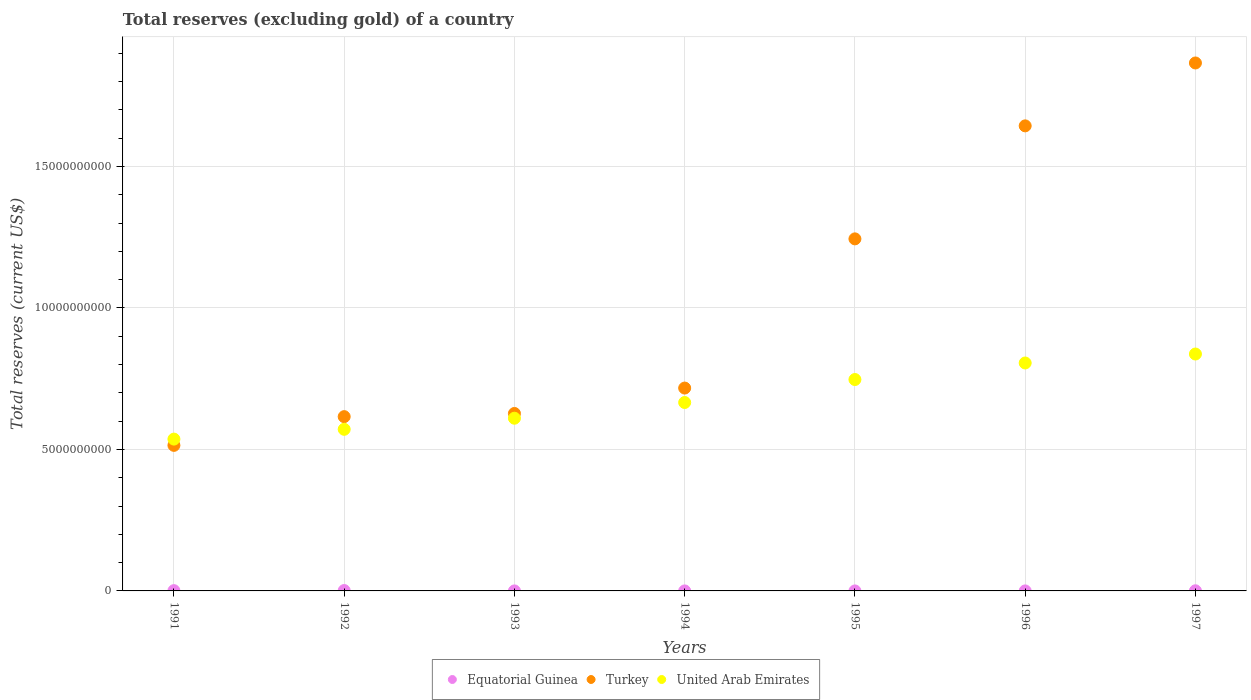What is the total reserves (excluding gold) in United Arab Emirates in 1991?
Your answer should be compact. 5.37e+09. Across all years, what is the maximum total reserves (excluding gold) in United Arab Emirates?
Your answer should be very brief. 8.37e+09. Across all years, what is the minimum total reserves (excluding gold) in Equatorial Guinea?
Your response must be concise. 4.08e+04. In which year was the total reserves (excluding gold) in United Arab Emirates minimum?
Your response must be concise. 1991. What is the total total reserves (excluding gold) in Turkey in the graph?
Ensure brevity in your answer.  7.23e+1. What is the difference between the total reserves (excluding gold) in United Arab Emirates in 1994 and that in 1997?
Offer a very short reply. -1.71e+09. What is the difference between the total reserves (excluding gold) in Equatorial Guinea in 1991 and the total reserves (excluding gold) in United Arab Emirates in 1994?
Your response must be concise. -6.65e+09. What is the average total reserves (excluding gold) in United Arab Emirates per year?
Offer a very short reply. 6.82e+09. In the year 1997, what is the difference between the total reserves (excluding gold) in Equatorial Guinea and total reserves (excluding gold) in Turkey?
Ensure brevity in your answer.  -1.87e+1. What is the ratio of the total reserves (excluding gold) in Equatorial Guinea in 1991 to that in 1997?
Ensure brevity in your answer.  1.92. What is the difference between the highest and the second highest total reserves (excluding gold) in Equatorial Guinea?
Provide a succinct answer. 3.93e+06. What is the difference between the highest and the lowest total reserves (excluding gold) in Turkey?
Give a very brief answer. 1.35e+1. Is the sum of the total reserves (excluding gold) in Equatorial Guinea in 1992 and 1996 greater than the maximum total reserves (excluding gold) in Turkey across all years?
Give a very brief answer. No. Is the total reserves (excluding gold) in Turkey strictly greater than the total reserves (excluding gold) in Equatorial Guinea over the years?
Provide a short and direct response. Yes. What is the difference between two consecutive major ticks on the Y-axis?
Ensure brevity in your answer.  5.00e+09. Does the graph contain any zero values?
Provide a short and direct response. No. How many legend labels are there?
Offer a very short reply. 3. How are the legend labels stacked?
Keep it short and to the point. Horizontal. What is the title of the graph?
Offer a very short reply. Total reserves (excluding gold) of a country. Does "Barbados" appear as one of the legend labels in the graph?
Make the answer very short. No. What is the label or title of the Y-axis?
Your response must be concise. Total reserves (current US$). What is the Total reserves (current US$) of Equatorial Guinea in 1991?
Your response must be concise. 9.47e+06. What is the Total reserves (current US$) in Turkey in 1991?
Provide a short and direct response. 5.14e+09. What is the Total reserves (current US$) of United Arab Emirates in 1991?
Offer a very short reply. 5.37e+09. What is the Total reserves (current US$) of Equatorial Guinea in 1992?
Your response must be concise. 1.34e+07. What is the Total reserves (current US$) of Turkey in 1992?
Provide a succinct answer. 6.16e+09. What is the Total reserves (current US$) in United Arab Emirates in 1992?
Give a very brief answer. 5.71e+09. What is the Total reserves (current US$) of Equatorial Guinea in 1993?
Give a very brief answer. 4.81e+05. What is the Total reserves (current US$) of Turkey in 1993?
Provide a short and direct response. 6.27e+09. What is the Total reserves (current US$) of United Arab Emirates in 1993?
Give a very brief answer. 6.10e+09. What is the Total reserves (current US$) in Equatorial Guinea in 1994?
Your answer should be very brief. 3.90e+05. What is the Total reserves (current US$) in Turkey in 1994?
Your answer should be very brief. 7.17e+09. What is the Total reserves (current US$) in United Arab Emirates in 1994?
Ensure brevity in your answer.  6.66e+09. What is the Total reserves (current US$) of Equatorial Guinea in 1995?
Offer a very short reply. 4.08e+04. What is the Total reserves (current US$) in Turkey in 1995?
Your answer should be very brief. 1.24e+1. What is the Total reserves (current US$) in United Arab Emirates in 1995?
Provide a short and direct response. 7.47e+09. What is the Total reserves (current US$) of Equatorial Guinea in 1996?
Make the answer very short. 5.16e+05. What is the Total reserves (current US$) in Turkey in 1996?
Your answer should be very brief. 1.64e+1. What is the Total reserves (current US$) in United Arab Emirates in 1996?
Your answer should be very brief. 8.06e+09. What is the Total reserves (current US$) of Equatorial Guinea in 1997?
Make the answer very short. 4.93e+06. What is the Total reserves (current US$) in Turkey in 1997?
Give a very brief answer. 1.87e+1. What is the Total reserves (current US$) of United Arab Emirates in 1997?
Ensure brevity in your answer.  8.37e+09. Across all years, what is the maximum Total reserves (current US$) of Equatorial Guinea?
Your answer should be very brief. 1.34e+07. Across all years, what is the maximum Total reserves (current US$) in Turkey?
Offer a very short reply. 1.87e+1. Across all years, what is the maximum Total reserves (current US$) of United Arab Emirates?
Your answer should be very brief. 8.37e+09. Across all years, what is the minimum Total reserves (current US$) of Equatorial Guinea?
Give a very brief answer. 4.08e+04. Across all years, what is the minimum Total reserves (current US$) in Turkey?
Your answer should be very brief. 5.14e+09. Across all years, what is the minimum Total reserves (current US$) in United Arab Emirates?
Your response must be concise. 5.37e+09. What is the total Total reserves (current US$) of Equatorial Guinea in the graph?
Make the answer very short. 2.92e+07. What is the total Total reserves (current US$) of Turkey in the graph?
Make the answer very short. 7.23e+1. What is the total Total reserves (current US$) in United Arab Emirates in the graph?
Your answer should be very brief. 4.77e+1. What is the difference between the Total reserves (current US$) of Equatorial Guinea in 1991 and that in 1992?
Make the answer very short. -3.93e+06. What is the difference between the Total reserves (current US$) of Turkey in 1991 and that in 1992?
Ensure brevity in your answer.  -1.02e+09. What is the difference between the Total reserves (current US$) of United Arab Emirates in 1991 and that in 1992?
Your answer should be very brief. -3.46e+08. What is the difference between the Total reserves (current US$) in Equatorial Guinea in 1991 and that in 1993?
Make the answer very short. 8.99e+06. What is the difference between the Total reserves (current US$) in Turkey in 1991 and that in 1993?
Provide a succinct answer. -1.13e+09. What is the difference between the Total reserves (current US$) of United Arab Emirates in 1991 and that in 1993?
Your answer should be very brief. -7.38e+08. What is the difference between the Total reserves (current US$) in Equatorial Guinea in 1991 and that in 1994?
Provide a short and direct response. 9.08e+06. What is the difference between the Total reserves (current US$) of Turkey in 1991 and that in 1994?
Offer a very short reply. -2.03e+09. What is the difference between the Total reserves (current US$) in United Arab Emirates in 1991 and that in 1994?
Provide a short and direct response. -1.29e+09. What is the difference between the Total reserves (current US$) of Equatorial Guinea in 1991 and that in 1995?
Ensure brevity in your answer.  9.43e+06. What is the difference between the Total reserves (current US$) of Turkey in 1991 and that in 1995?
Provide a short and direct response. -7.30e+09. What is the difference between the Total reserves (current US$) of United Arab Emirates in 1991 and that in 1995?
Your response must be concise. -2.11e+09. What is the difference between the Total reserves (current US$) of Equatorial Guinea in 1991 and that in 1996?
Give a very brief answer. 8.96e+06. What is the difference between the Total reserves (current US$) of Turkey in 1991 and that in 1996?
Your answer should be compact. -1.13e+1. What is the difference between the Total reserves (current US$) in United Arab Emirates in 1991 and that in 1996?
Provide a short and direct response. -2.69e+09. What is the difference between the Total reserves (current US$) of Equatorial Guinea in 1991 and that in 1997?
Make the answer very short. 4.54e+06. What is the difference between the Total reserves (current US$) in Turkey in 1991 and that in 1997?
Your response must be concise. -1.35e+1. What is the difference between the Total reserves (current US$) of United Arab Emirates in 1991 and that in 1997?
Offer a very short reply. -3.01e+09. What is the difference between the Total reserves (current US$) in Equatorial Guinea in 1992 and that in 1993?
Ensure brevity in your answer.  1.29e+07. What is the difference between the Total reserves (current US$) in Turkey in 1992 and that in 1993?
Your answer should be compact. -1.12e+08. What is the difference between the Total reserves (current US$) in United Arab Emirates in 1992 and that in 1993?
Ensure brevity in your answer.  -3.92e+08. What is the difference between the Total reserves (current US$) of Equatorial Guinea in 1992 and that in 1994?
Offer a very short reply. 1.30e+07. What is the difference between the Total reserves (current US$) in Turkey in 1992 and that in 1994?
Your response must be concise. -1.01e+09. What is the difference between the Total reserves (current US$) of United Arab Emirates in 1992 and that in 1994?
Offer a very short reply. -9.47e+08. What is the difference between the Total reserves (current US$) of Equatorial Guinea in 1992 and that in 1995?
Keep it short and to the point. 1.34e+07. What is the difference between the Total reserves (current US$) of Turkey in 1992 and that in 1995?
Your answer should be very brief. -6.28e+09. What is the difference between the Total reserves (current US$) of United Arab Emirates in 1992 and that in 1995?
Provide a short and direct response. -1.76e+09. What is the difference between the Total reserves (current US$) of Equatorial Guinea in 1992 and that in 1996?
Provide a short and direct response. 1.29e+07. What is the difference between the Total reserves (current US$) in Turkey in 1992 and that in 1996?
Your answer should be compact. -1.03e+1. What is the difference between the Total reserves (current US$) of United Arab Emirates in 1992 and that in 1996?
Your answer should be very brief. -2.34e+09. What is the difference between the Total reserves (current US$) of Equatorial Guinea in 1992 and that in 1997?
Provide a short and direct response. 8.48e+06. What is the difference between the Total reserves (current US$) in Turkey in 1992 and that in 1997?
Your answer should be compact. -1.25e+1. What is the difference between the Total reserves (current US$) in United Arab Emirates in 1992 and that in 1997?
Provide a short and direct response. -2.66e+09. What is the difference between the Total reserves (current US$) of Equatorial Guinea in 1993 and that in 1994?
Offer a very short reply. 9.05e+04. What is the difference between the Total reserves (current US$) of Turkey in 1993 and that in 1994?
Make the answer very short. -8.98e+08. What is the difference between the Total reserves (current US$) of United Arab Emirates in 1993 and that in 1994?
Your answer should be compact. -5.55e+08. What is the difference between the Total reserves (current US$) in Equatorial Guinea in 1993 and that in 1995?
Your answer should be very brief. 4.40e+05. What is the difference between the Total reserves (current US$) of Turkey in 1993 and that in 1995?
Offer a very short reply. -6.17e+09. What is the difference between the Total reserves (current US$) of United Arab Emirates in 1993 and that in 1995?
Provide a short and direct response. -1.37e+09. What is the difference between the Total reserves (current US$) of Equatorial Guinea in 1993 and that in 1996?
Provide a succinct answer. -3.57e+04. What is the difference between the Total reserves (current US$) in Turkey in 1993 and that in 1996?
Give a very brief answer. -1.02e+1. What is the difference between the Total reserves (current US$) of United Arab Emirates in 1993 and that in 1996?
Keep it short and to the point. -1.95e+09. What is the difference between the Total reserves (current US$) of Equatorial Guinea in 1993 and that in 1997?
Provide a succinct answer. -4.45e+06. What is the difference between the Total reserves (current US$) in Turkey in 1993 and that in 1997?
Make the answer very short. -1.24e+1. What is the difference between the Total reserves (current US$) in United Arab Emirates in 1993 and that in 1997?
Offer a terse response. -2.27e+09. What is the difference between the Total reserves (current US$) in Equatorial Guinea in 1994 and that in 1995?
Your answer should be compact. 3.50e+05. What is the difference between the Total reserves (current US$) of Turkey in 1994 and that in 1995?
Provide a short and direct response. -5.27e+09. What is the difference between the Total reserves (current US$) of United Arab Emirates in 1994 and that in 1995?
Keep it short and to the point. -8.12e+08. What is the difference between the Total reserves (current US$) in Equatorial Guinea in 1994 and that in 1996?
Make the answer very short. -1.26e+05. What is the difference between the Total reserves (current US$) in Turkey in 1994 and that in 1996?
Provide a short and direct response. -9.27e+09. What is the difference between the Total reserves (current US$) in United Arab Emirates in 1994 and that in 1996?
Make the answer very short. -1.40e+09. What is the difference between the Total reserves (current US$) in Equatorial Guinea in 1994 and that in 1997?
Provide a short and direct response. -4.54e+06. What is the difference between the Total reserves (current US$) in Turkey in 1994 and that in 1997?
Offer a terse response. -1.15e+1. What is the difference between the Total reserves (current US$) of United Arab Emirates in 1994 and that in 1997?
Offer a very short reply. -1.71e+09. What is the difference between the Total reserves (current US$) in Equatorial Guinea in 1995 and that in 1996?
Offer a very short reply. -4.76e+05. What is the difference between the Total reserves (current US$) of Turkey in 1995 and that in 1996?
Provide a short and direct response. -3.99e+09. What is the difference between the Total reserves (current US$) of United Arab Emirates in 1995 and that in 1996?
Your answer should be compact. -5.85e+08. What is the difference between the Total reserves (current US$) in Equatorial Guinea in 1995 and that in 1997?
Offer a terse response. -4.89e+06. What is the difference between the Total reserves (current US$) in Turkey in 1995 and that in 1997?
Offer a very short reply. -6.22e+09. What is the difference between the Total reserves (current US$) in United Arab Emirates in 1995 and that in 1997?
Provide a short and direct response. -9.01e+08. What is the difference between the Total reserves (current US$) of Equatorial Guinea in 1996 and that in 1997?
Give a very brief answer. -4.42e+06. What is the difference between the Total reserves (current US$) in Turkey in 1996 and that in 1997?
Offer a terse response. -2.22e+09. What is the difference between the Total reserves (current US$) in United Arab Emirates in 1996 and that in 1997?
Your answer should be compact. -3.17e+08. What is the difference between the Total reserves (current US$) in Equatorial Guinea in 1991 and the Total reserves (current US$) in Turkey in 1992?
Your response must be concise. -6.15e+09. What is the difference between the Total reserves (current US$) in Equatorial Guinea in 1991 and the Total reserves (current US$) in United Arab Emirates in 1992?
Ensure brevity in your answer.  -5.70e+09. What is the difference between the Total reserves (current US$) of Turkey in 1991 and the Total reserves (current US$) of United Arab Emirates in 1992?
Ensure brevity in your answer.  -5.68e+08. What is the difference between the Total reserves (current US$) of Equatorial Guinea in 1991 and the Total reserves (current US$) of Turkey in 1993?
Offer a terse response. -6.26e+09. What is the difference between the Total reserves (current US$) in Equatorial Guinea in 1991 and the Total reserves (current US$) in United Arab Emirates in 1993?
Your response must be concise. -6.09e+09. What is the difference between the Total reserves (current US$) of Turkey in 1991 and the Total reserves (current US$) of United Arab Emirates in 1993?
Your response must be concise. -9.60e+08. What is the difference between the Total reserves (current US$) in Equatorial Guinea in 1991 and the Total reserves (current US$) in Turkey in 1994?
Offer a terse response. -7.16e+09. What is the difference between the Total reserves (current US$) of Equatorial Guinea in 1991 and the Total reserves (current US$) of United Arab Emirates in 1994?
Ensure brevity in your answer.  -6.65e+09. What is the difference between the Total reserves (current US$) of Turkey in 1991 and the Total reserves (current US$) of United Arab Emirates in 1994?
Your response must be concise. -1.51e+09. What is the difference between the Total reserves (current US$) of Equatorial Guinea in 1991 and the Total reserves (current US$) of Turkey in 1995?
Provide a succinct answer. -1.24e+1. What is the difference between the Total reserves (current US$) of Equatorial Guinea in 1991 and the Total reserves (current US$) of United Arab Emirates in 1995?
Your answer should be compact. -7.46e+09. What is the difference between the Total reserves (current US$) of Turkey in 1991 and the Total reserves (current US$) of United Arab Emirates in 1995?
Offer a terse response. -2.33e+09. What is the difference between the Total reserves (current US$) of Equatorial Guinea in 1991 and the Total reserves (current US$) of Turkey in 1996?
Ensure brevity in your answer.  -1.64e+1. What is the difference between the Total reserves (current US$) of Equatorial Guinea in 1991 and the Total reserves (current US$) of United Arab Emirates in 1996?
Provide a short and direct response. -8.05e+09. What is the difference between the Total reserves (current US$) of Turkey in 1991 and the Total reserves (current US$) of United Arab Emirates in 1996?
Offer a terse response. -2.91e+09. What is the difference between the Total reserves (current US$) in Equatorial Guinea in 1991 and the Total reserves (current US$) in Turkey in 1997?
Ensure brevity in your answer.  -1.86e+1. What is the difference between the Total reserves (current US$) of Equatorial Guinea in 1991 and the Total reserves (current US$) of United Arab Emirates in 1997?
Make the answer very short. -8.36e+09. What is the difference between the Total reserves (current US$) of Turkey in 1991 and the Total reserves (current US$) of United Arab Emirates in 1997?
Provide a succinct answer. -3.23e+09. What is the difference between the Total reserves (current US$) of Equatorial Guinea in 1992 and the Total reserves (current US$) of Turkey in 1993?
Give a very brief answer. -6.26e+09. What is the difference between the Total reserves (current US$) in Equatorial Guinea in 1992 and the Total reserves (current US$) in United Arab Emirates in 1993?
Give a very brief answer. -6.09e+09. What is the difference between the Total reserves (current US$) of Turkey in 1992 and the Total reserves (current US$) of United Arab Emirates in 1993?
Provide a short and direct response. 5.57e+07. What is the difference between the Total reserves (current US$) of Equatorial Guinea in 1992 and the Total reserves (current US$) of Turkey in 1994?
Ensure brevity in your answer.  -7.16e+09. What is the difference between the Total reserves (current US$) of Equatorial Guinea in 1992 and the Total reserves (current US$) of United Arab Emirates in 1994?
Keep it short and to the point. -6.65e+09. What is the difference between the Total reserves (current US$) of Turkey in 1992 and the Total reserves (current US$) of United Arab Emirates in 1994?
Offer a terse response. -4.99e+08. What is the difference between the Total reserves (current US$) in Equatorial Guinea in 1992 and the Total reserves (current US$) in Turkey in 1995?
Provide a succinct answer. -1.24e+1. What is the difference between the Total reserves (current US$) in Equatorial Guinea in 1992 and the Total reserves (current US$) in United Arab Emirates in 1995?
Provide a short and direct response. -7.46e+09. What is the difference between the Total reserves (current US$) in Turkey in 1992 and the Total reserves (current US$) in United Arab Emirates in 1995?
Provide a short and direct response. -1.31e+09. What is the difference between the Total reserves (current US$) in Equatorial Guinea in 1992 and the Total reserves (current US$) in Turkey in 1996?
Ensure brevity in your answer.  -1.64e+1. What is the difference between the Total reserves (current US$) of Equatorial Guinea in 1992 and the Total reserves (current US$) of United Arab Emirates in 1996?
Your answer should be very brief. -8.04e+09. What is the difference between the Total reserves (current US$) in Turkey in 1992 and the Total reserves (current US$) in United Arab Emirates in 1996?
Offer a very short reply. -1.90e+09. What is the difference between the Total reserves (current US$) of Equatorial Guinea in 1992 and the Total reserves (current US$) of Turkey in 1997?
Ensure brevity in your answer.  -1.86e+1. What is the difference between the Total reserves (current US$) of Equatorial Guinea in 1992 and the Total reserves (current US$) of United Arab Emirates in 1997?
Offer a very short reply. -8.36e+09. What is the difference between the Total reserves (current US$) in Turkey in 1992 and the Total reserves (current US$) in United Arab Emirates in 1997?
Provide a short and direct response. -2.21e+09. What is the difference between the Total reserves (current US$) of Equatorial Guinea in 1993 and the Total reserves (current US$) of Turkey in 1994?
Offer a very short reply. -7.17e+09. What is the difference between the Total reserves (current US$) of Equatorial Guinea in 1993 and the Total reserves (current US$) of United Arab Emirates in 1994?
Ensure brevity in your answer.  -6.66e+09. What is the difference between the Total reserves (current US$) of Turkey in 1993 and the Total reserves (current US$) of United Arab Emirates in 1994?
Your answer should be compact. -3.87e+08. What is the difference between the Total reserves (current US$) in Equatorial Guinea in 1993 and the Total reserves (current US$) in Turkey in 1995?
Offer a terse response. -1.24e+1. What is the difference between the Total reserves (current US$) in Equatorial Guinea in 1993 and the Total reserves (current US$) in United Arab Emirates in 1995?
Make the answer very short. -7.47e+09. What is the difference between the Total reserves (current US$) of Turkey in 1993 and the Total reserves (current US$) of United Arab Emirates in 1995?
Your answer should be compact. -1.20e+09. What is the difference between the Total reserves (current US$) of Equatorial Guinea in 1993 and the Total reserves (current US$) of Turkey in 1996?
Make the answer very short. -1.64e+1. What is the difference between the Total reserves (current US$) of Equatorial Guinea in 1993 and the Total reserves (current US$) of United Arab Emirates in 1996?
Offer a very short reply. -8.06e+09. What is the difference between the Total reserves (current US$) of Turkey in 1993 and the Total reserves (current US$) of United Arab Emirates in 1996?
Offer a terse response. -1.78e+09. What is the difference between the Total reserves (current US$) of Equatorial Guinea in 1993 and the Total reserves (current US$) of Turkey in 1997?
Provide a succinct answer. -1.87e+1. What is the difference between the Total reserves (current US$) in Equatorial Guinea in 1993 and the Total reserves (current US$) in United Arab Emirates in 1997?
Ensure brevity in your answer.  -8.37e+09. What is the difference between the Total reserves (current US$) of Turkey in 1993 and the Total reserves (current US$) of United Arab Emirates in 1997?
Your answer should be compact. -2.10e+09. What is the difference between the Total reserves (current US$) in Equatorial Guinea in 1994 and the Total reserves (current US$) in Turkey in 1995?
Provide a succinct answer. -1.24e+1. What is the difference between the Total reserves (current US$) of Equatorial Guinea in 1994 and the Total reserves (current US$) of United Arab Emirates in 1995?
Make the answer very short. -7.47e+09. What is the difference between the Total reserves (current US$) in Turkey in 1994 and the Total reserves (current US$) in United Arab Emirates in 1995?
Your answer should be compact. -3.02e+08. What is the difference between the Total reserves (current US$) in Equatorial Guinea in 1994 and the Total reserves (current US$) in Turkey in 1996?
Offer a terse response. -1.64e+1. What is the difference between the Total reserves (current US$) in Equatorial Guinea in 1994 and the Total reserves (current US$) in United Arab Emirates in 1996?
Provide a succinct answer. -8.06e+09. What is the difference between the Total reserves (current US$) in Turkey in 1994 and the Total reserves (current US$) in United Arab Emirates in 1996?
Keep it short and to the point. -8.86e+08. What is the difference between the Total reserves (current US$) in Equatorial Guinea in 1994 and the Total reserves (current US$) in Turkey in 1997?
Ensure brevity in your answer.  -1.87e+1. What is the difference between the Total reserves (current US$) in Equatorial Guinea in 1994 and the Total reserves (current US$) in United Arab Emirates in 1997?
Make the answer very short. -8.37e+09. What is the difference between the Total reserves (current US$) of Turkey in 1994 and the Total reserves (current US$) of United Arab Emirates in 1997?
Keep it short and to the point. -1.20e+09. What is the difference between the Total reserves (current US$) of Equatorial Guinea in 1995 and the Total reserves (current US$) of Turkey in 1996?
Provide a short and direct response. -1.64e+1. What is the difference between the Total reserves (current US$) in Equatorial Guinea in 1995 and the Total reserves (current US$) in United Arab Emirates in 1996?
Offer a terse response. -8.06e+09. What is the difference between the Total reserves (current US$) of Turkey in 1995 and the Total reserves (current US$) of United Arab Emirates in 1996?
Your answer should be very brief. 4.39e+09. What is the difference between the Total reserves (current US$) of Equatorial Guinea in 1995 and the Total reserves (current US$) of Turkey in 1997?
Make the answer very short. -1.87e+1. What is the difference between the Total reserves (current US$) in Equatorial Guinea in 1995 and the Total reserves (current US$) in United Arab Emirates in 1997?
Keep it short and to the point. -8.37e+09. What is the difference between the Total reserves (current US$) of Turkey in 1995 and the Total reserves (current US$) of United Arab Emirates in 1997?
Make the answer very short. 4.07e+09. What is the difference between the Total reserves (current US$) of Equatorial Guinea in 1996 and the Total reserves (current US$) of Turkey in 1997?
Keep it short and to the point. -1.87e+1. What is the difference between the Total reserves (current US$) of Equatorial Guinea in 1996 and the Total reserves (current US$) of United Arab Emirates in 1997?
Give a very brief answer. -8.37e+09. What is the difference between the Total reserves (current US$) of Turkey in 1996 and the Total reserves (current US$) of United Arab Emirates in 1997?
Offer a terse response. 8.06e+09. What is the average Total reserves (current US$) in Equatorial Guinea per year?
Offer a terse response. 4.18e+06. What is the average Total reserves (current US$) in Turkey per year?
Offer a terse response. 1.03e+1. What is the average Total reserves (current US$) of United Arab Emirates per year?
Keep it short and to the point. 6.82e+09. In the year 1991, what is the difference between the Total reserves (current US$) of Equatorial Guinea and Total reserves (current US$) of Turkey?
Keep it short and to the point. -5.13e+09. In the year 1991, what is the difference between the Total reserves (current US$) in Equatorial Guinea and Total reserves (current US$) in United Arab Emirates?
Offer a very short reply. -5.36e+09. In the year 1991, what is the difference between the Total reserves (current US$) in Turkey and Total reserves (current US$) in United Arab Emirates?
Your answer should be very brief. -2.21e+08. In the year 1992, what is the difference between the Total reserves (current US$) of Equatorial Guinea and Total reserves (current US$) of Turkey?
Your answer should be compact. -6.15e+09. In the year 1992, what is the difference between the Total reserves (current US$) in Equatorial Guinea and Total reserves (current US$) in United Arab Emirates?
Your response must be concise. -5.70e+09. In the year 1992, what is the difference between the Total reserves (current US$) in Turkey and Total reserves (current US$) in United Arab Emirates?
Your answer should be compact. 4.48e+08. In the year 1993, what is the difference between the Total reserves (current US$) of Equatorial Guinea and Total reserves (current US$) of Turkey?
Offer a terse response. -6.27e+09. In the year 1993, what is the difference between the Total reserves (current US$) in Equatorial Guinea and Total reserves (current US$) in United Arab Emirates?
Ensure brevity in your answer.  -6.10e+09. In the year 1993, what is the difference between the Total reserves (current US$) in Turkey and Total reserves (current US$) in United Arab Emirates?
Provide a succinct answer. 1.68e+08. In the year 1994, what is the difference between the Total reserves (current US$) of Equatorial Guinea and Total reserves (current US$) of Turkey?
Offer a terse response. -7.17e+09. In the year 1994, what is the difference between the Total reserves (current US$) of Equatorial Guinea and Total reserves (current US$) of United Arab Emirates?
Make the answer very short. -6.66e+09. In the year 1994, what is the difference between the Total reserves (current US$) in Turkey and Total reserves (current US$) in United Arab Emirates?
Ensure brevity in your answer.  5.11e+08. In the year 1995, what is the difference between the Total reserves (current US$) in Equatorial Guinea and Total reserves (current US$) in Turkey?
Make the answer very short. -1.24e+1. In the year 1995, what is the difference between the Total reserves (current US$) in Equatorial Guinea and Total reserves (current US$) in United Arab Emirates?
Ensure brevity in your answer.  -7.47e+09. In the year 1995, what is the difference between the Total reserves (current US$) in Turkey and Total reserves (current US$) in United Arab Emirates?
Your response must be concise. 4.97e+09. In the year 1996, what is the difference between the Total reserves (current US$) of Equatorial Guinea and Total reserves (current US$) of Turkey?
Your response must be concise. -1.64e+1. In the year 1996, what is the difference between the Total reserves (current US$) in Equatorial Guinea and Total reserves (current US$) in United Arab Emirates?
Your answer should be very brief. -8.05e+09. In the year 1996, what is the difference between the Total reserves (current US$) in Turkey and Total reserves (current US$) in United Arab Emirates?
Provide a succinct answer. 8.38e+09. In the year 1997, what is the difference between the Total reserves (current US$) in Equatorial Guinea and Total reserves (current US$) in Turkey?
Give a very brief answer. -1.87e+1. In the year 1997, what is the difference between the Total reserves (current US$) of Equatorial Guinea and Total reserves (current US$) of United Arab Emirates?
Offer a very short reply. -8.37e+09. In the year 1997, what is the difference between the Total reserves (current US$) in Turkey and Total reserves (current US$) in United Arab Emirates?
Keep it short and to the point. 1.03e+1. What is the ratio of the Total reserves (current US$) in Equatorial Guinea in 1991 to that in 1992?
Offer a terse response. 0.71. What is the ratio of the Total reserves (current US$) of Turkey in 1991 to that in 1992?
Ensure brevity in your answer.  0.84. What is the ratio of the Total reserves (current US$) in United Arab Emirates in 1991 to that in 1992?
Your answer should be compact. 0.94. What is the ratio of the Total reserves (current US$) of Equatorial Guinea in 1991 to that in 1993?
Offer a terse response. 19.7. What is the ratio of the Total reserves (current US$) in Turkey in 1991 to that in 1993?
Your answer should be very brief. 0.82. What is the ratio of the Total reserves (current US$) of United Arab Emirates in 1991 to that in 1993?
Provide a short and direct response. 0.88. What is the ratio of the Total reserves (current US$) in Equatorial Guinea in 1991 to that in 1994?
Your response must be concise. 24.27. What is the ratio of the Total reserves (current US$) in Turkey in 1991 to that in 1994?
Offer a terse response. 0.72. What is the ratio of the Total reserves (current US$) of United Arab Emirates in 1991 to that in 1994?
Your answer should be compact. 0.81. What is the ratio of the Total reserves (current US$) in Equatorial Guinea in 1991 to that in 1995?
Give a very brief answer. 232.13. What is the ratio of the Total reserves (current US$) of Turkey in 1991 to that in 1995?
Make the answer very short. 0.41. What is the ratio of the Total reserves (current US$) of United Arab Emirates in 1991 to that in 1995?
Provide a short and direct response. 0.72. What is the ratio of the Total reserves (current US$) in Equatorial Guinea in 1991 to that in 1996?
Provide a short and direct response. 18.34. What is the ratio of the Total reserves (current US$) of Turkey in 1991 to that in 1996?
Ensure brevity in your answer.  0.31. What is the ratio of the Total reserves (current US$) in United Arab Emirates in 1991 to that in 1996?
Your answer should be very brief. 0.67. What is the ratio of the Total reserves (current US$) of Equatorial Guinea in 1991 to that in 1997?
Offer a terse response. 1.92. What is the ratio of the Total reserves (current US$) of Turkey in 1991 to that in 1997?
Give a very brief answer. 0.28. What is the ratio of the Total reserves (current US$) of United Arab Emirates in 1991 to that in 1997?
Your answer should be compact. 0.64. What is the ratio of the Total reserves (current US$) of Equatorial Guinea in 1992 to that in 1993?
Offer a terse response. 27.89. What is the ratio of the Total reserves (current US$) in Turkey in 1992 to that in 1993?
Offer a terse response. 0.98. What is the ratio of the Total reserves (current US$) in United Arab Emirates in 1992 to that in 1993?
Your answer should be very brief. 0.94. What is the ratio of the Total reserves (current US$) in Equatorial Guinea in 1992 to that in 1994?
Offer a very short reply. 34.35. What is the ratio of the Total reserves (current US$) in Turkey in 1992 to that in 1994?
Your response must be concise. 0.86. What is the ratio of the Total reserves (current US$) of United Arab Emirates in 1992 to that in 1994?
Give a very brief answer. 0.86. What is the ratio of the Total reserves (current US$) in Equatorial Guinea in 1992 to that in 1995?
Ensure brevity in your answer.  328.54. What is the ratio of the Total reserves (current US$) in Turkey in 1992 to that in 1995?
Make the answer very short. 0.5. What is the ratio of the Total reserves (current US$) in United Arab Emirates in 1992 to that in 1995?
Provide a short and direct response. 0.76. What is the ratio of the Total reserves (current US$) in Equatorial Guinea in 1992 to that in 1996?
Give a very brief answer. 25.96. What is the ratio of the Total reserves (current US$) in Turkey in 1992 to that in 1996?
Offer a terse response. 0.37. What is the ratio of the Total reserves (current US$) in United Arab Emirates in 1992 to that in 1996?
Offer a very short reply. 0.71. What is the ratio of the Total reserves (current US$) of Equatorial Guinea in 1992 to that in 1997?
Make the answer very short. 2.72. What is the ratio of the Total reserves (current US$) of Turkey in 1992 to that in 1997?
Provide a short and direct response. 0.33. What is the ratio of the Total reserves (current US$) in United Arab Emirates in 1992 to that in 1997?
Ensure brevity in your answer.  0.68. What is the ratio of the Total reserves (current US$) of Equatorial Guinea in 1993 to that in 1994?
Your response must be concise. 1.23. What is the ratio of the Total reserves (current US$) in Turkey in 1993 to that in 1994?
Ensure brevity in your answer.  0.87. What is the ratio of the Total reserves (current US$) in United Arab Emirates in 1993 to that in 1994?
Keep it short and to the point. 0.92. What is the ratio of the Total reserves (current US$) of Equatorial Guinea in 1993 to that in 1995?
Provide a short and direct response. 11.78. What is the ratio of the Total reserves (current US$) of Turkey in 1993 to that in 1995?
Provide a succinct answer. 0.5. What is the ratio of the Total reserves (current US$) in United Arab Emirates in 1993 to that in 1995?
Your answer should be very brief. 0.82. What is the ratio of the Total reserves (current US$) in Equatorial Guinea in 1993 to that in 1996?
Your response must be concise. 0.93. What is the ratio of the Total reserves (current US$) in Turkey in 1993 to that in 1996?
Keep it short and to the point. 0.38. What is the ratio of the Total reserves (current US$) of United Arab Emirates in 1993 to that in 1996?
Ensure brevity in your answer.  0.76. What is the ratio of the Total reserves (current US$) in Equatorial Guinea in 1993 to that in 1997?
Keep it short and to the point. 0.1. What is the ratio of the Total reserves (current US$) of Turkey in 1993 to that in 1997?
Keep it short and to the point. 0.34. What is the ratio of the Total reserves (current US$) in United Arab Emirates in 1993 to that in 1997?
Provide a short and direct response. 0.73. What is the ratio of the Total reserves (current US$) in Equatorial Guinea in 1994 to that in 1995?
Your answer should be compact. 9.56. What is the ratio of the Total reserves (current US$) of Turkey in 1994 to that in 1995?
Offer a very short reply. 0.58. What is the ratio of the Total reserves (current US$) in United Arab Emirates in 1994 to that in 1995?
Your response must be concise. 0.89. What is the ratio of the Total reserves (current US$) of Equatorial Guinea in 1994 to that in 1996?
Your response must be concise. 0.76. What is the ratio of the Total reserves (current US$) of Turkey in 1994 to that in 1996?
Keep it short and to the point. 0.44. What is the ratio of the Total reserves (current US$) in United Arab Emirates in 1994 to that in 1996?
Keep it short and to the point. 0.83. What is the ratio of the Total reserves (current US$) in Equatorial Guinea in 1994 to that in 1997?
Offer a very short reply. 0.08. What is the ratio of the Total reserves (current US$) of Turkey in 1994 to that in 1997?
Offer a very short reply. 0.38. What is the ratio of the Total reserves (current US$) in United Arab Emirates in 1994 to that in 1997?
Ensure brevity in your answer.  0.8. What is the ratio of the Total reserves (current US$) of Equatorial Guinea in 1995 to that in 1996?
Your response must be concise. 0.08. What is the ratio of the Total reserves (current US$) in Turkey in 1995 to that in 1996?
Keep it short and to the point. 0.76. What is the ratio of the Total reserves (current US$) in United Arab Emirates in 1995 to that in 1996?
Make the answer very short. 0.93. What is the ratio of the Total reserves (current US$) of Equatorial Guinea in 1995 to that in 1997?
Keep it short and to the point. 0.01. What is the ratio of the Total reserves (current US$) in Turkey in 1995 to that in 1997?
Offer a terse response. 0.67. What is the ratio of the Total reserves (current US$) in United Arab Emirates in 1995 to that in 1997?
Make the answer very short. 0.89. What is the ratio of the Total reserves (current US$) of Equatorial Guinea in 1996 to that in 1997?
Ensure brevity in your answer.  0.1. What is the ratio of the Total reserves (current US$) of Turkey in 1996 to that in 1997?
Your answer should be compact. 0.88. What is the ratio of the Total reserves (current US$) of United Arab Emirates in 1996 to that in 1997?
Provide a short and direct response. 0.96. What is the difference between the highest and the second highest Total reserves (current US$) of Equatorial Guinea?
Your answer should be very brief. 3.93e+06. What is the difference between the highest and the second highest Total reserves (current US$) in Turkey?
Give a very brief answer. 2.22e+09. What is the difference between the highest and the second highest Total reserves (current US$) of United Arab Emirates?
Offer a terse response. 3.17e+08. What is the difference between the highest and the lowest Total reserves (current US$) in Equatorial Guinea?
Give a very brief answer. 1.34e+07. What is the difference between the highest and the lowest Total reserves (current US$) of Turkey?
Give a very brief answer. 1.35e+1. What is the difference between the highest and the lowest Total reserves (current US$) in United Arab Emirates?
Provide a short and direct response. 3.01e+09. 